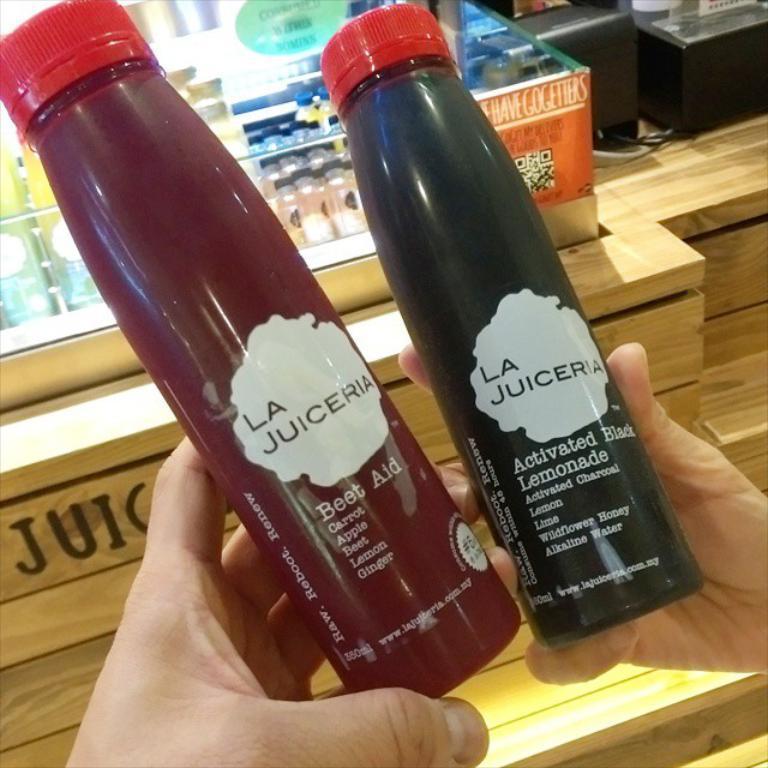How would you summarize this image in a sentence or two? These are the two juice bottles with red cap. These bottles are hold by a person in his hands. At background I can see group of bottles placed. 